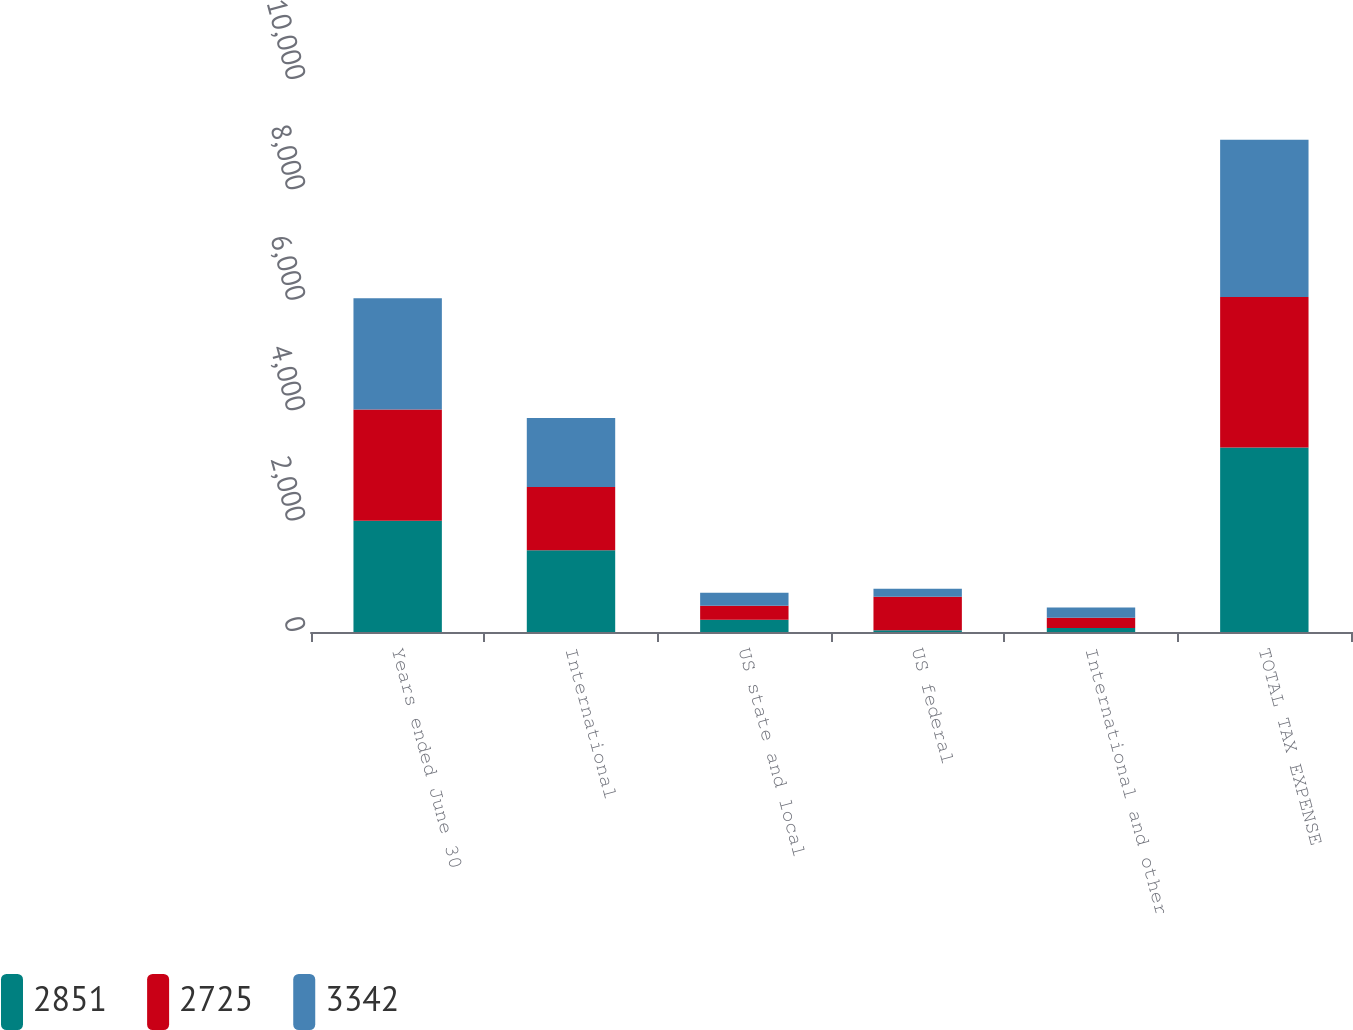Convert chart to OTSL. <chart><loc_0><loc_0><loc_500><loc_500><stacked_bar_chart><ecel><fcel>Years ended June 30<fcel>International<fcel>US state and local<fcel>US federal<fcel>International and other<fcel>TOTAL TAX EXPENSE<nl><fcel>2851<fcel>2016<fcel>1483<fcel>224<fcel>33<fcel>71<fcel>3342<nl><fcel>2725<fcel>2015<fcel>1142<fcel>252<fcel>607<fcel>189<fcel>2725<nl><fcel>3342<fcel>2014<fcel>1252<fcel>237<fcel>145<fcel>182<fcel>2851<nl></chart> 